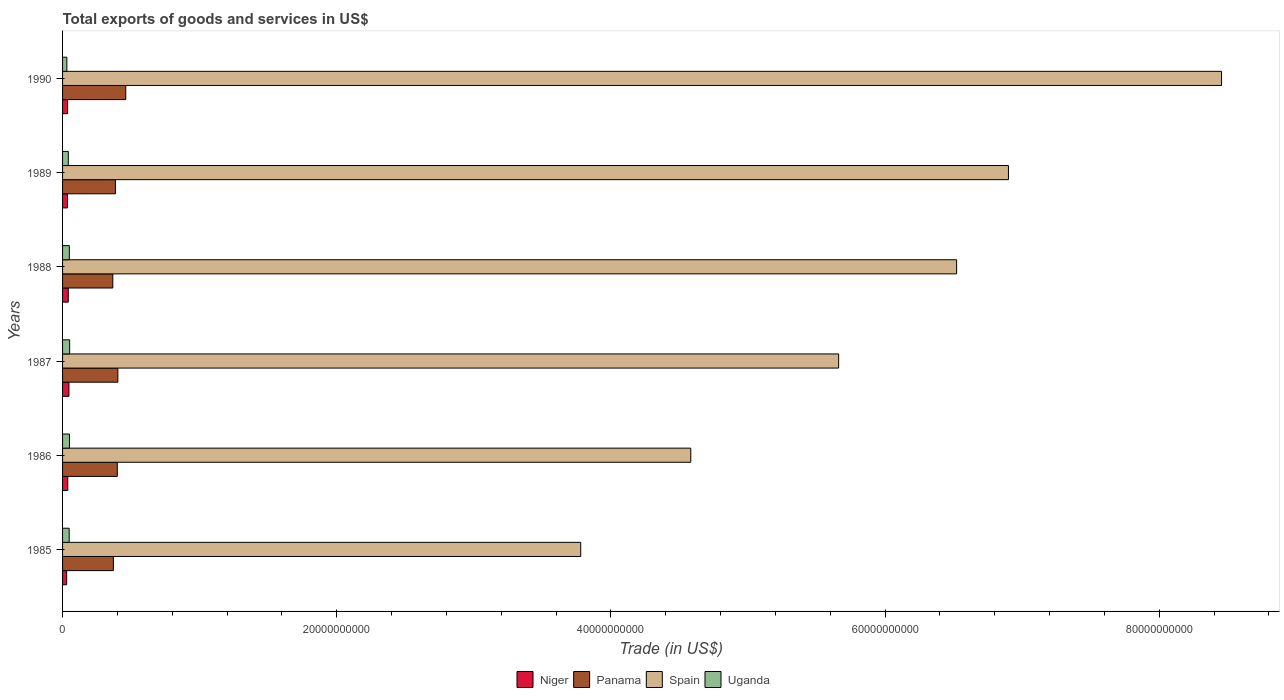How many different coloured bars are there?
Keep it short and to the point. 4. How many groups of bars are there?
Offer a very short reply. 6. Are the number of bars per tick equal to the number of legend labels?
Give a very brief answer. Yes. Are the number of bars on each tick of the Y-axis equal?
Ensure brevity in your answer.  Yes. How many bars are there on the 6th tick from the top?
Offer a very short reply. 4. How many bars are there on the 1st tick from the bottom?
Offer a terse response. 4. In how many cases, is the number of bars for a given year not equal to the number of legend labels?
Provide a succinct answer. 0. What is the total exports of goods and services in Niger in 1986?
Your answer should be compact. 3.81e+08. Across all years, what is the maximum total exports of goods and services in Niger?
Offer a very short reply. 4.65e+08. Across all years, what is the minimum total exports of goods and services in Uganda?
Provide a succinct answer. 3.12e+08. In which year was the total exports of goods and services in Spain maximum?
Your answer should be very brief. 1990. In which year was the total exports of goods and services in Spain minimum?
Your answer should be very brief. 1985. What is the total total exports of goods and services in Panama in the graph?
Ensure brevity in your answer.  2.39e+1. What is the difference between the total exports of goods and services in Niger in 1985 and that in 1988?
Give a very brief answer. -1.19e+08. What is the difference between the total exports of goods and services in Uganda in 1989 and the total exports of goods and services in Niger in 1986?
Your answer should be compact. 3.89e+07. What is the average total exports of goods and services in Spain per year?
Make the answer very short. 5.98e+1. In the year 1987, what is the difference between the total exports of goods and services in Uganda and total exports of goods and services in Spain?
Make the answer very short. -5.61e+1. What is the ratio of the total exports of goods and services in Spain in 1987 to that in 1989?
Your answer should be very brief. 0.82. What is the difference between the highest and the second highest total exports of goods and services in Spain?
Your answer should be compact. 1.55e+1. What is the difference between the highest and the lowest total exports of goods and services in Niger?
Offer a very short reply. 1.67e+08. In how many years, is the total exports of goods and services in Uganda greater than the average total exports of goods and services in Uganda taken over all years?
Offer a very short reply. 4. Is it the case that in every year, the sum of the total exports of goods and services in Uganda and total exports of goods and services in Panama is greater than the sum of total exports of goods and services in Niger and total exports of goods and services in Spain?
Your response must be concise. No. What does the 2nd bar from the top in 1990 represents?
Offer a very short reply. Spain. What does the 1st bar from the bottom in 1986 represents?
Ensure brevity in your answer.  Niger. Is it the case that in every year, the sum of the total exports of goods and services in Uganda and total exports of goods and services in Spain is greater than the total exports of goods and services in Niger?
Provide a short and direct response. Yes. How many bars are there?
Keep it short and to the point. 24. Are all the bars in the graph horizontal?
Your answer should be compact. Yes. How many years are there in the graph?
Provide a succinct answer. 6. Where does the legend appear in the graph?
Provide a short and direct response. Bottom center. How many legend labels are there?
Offer a very short reply. 4. What is the title of the graph?
Offer a very short reply. Total exports of goods and services in US$. Does "Tonga" appear as one of the legend labels in the graph?
Provide a succinct answer. No. What is the label or title of the X-axis?
Give a very brief answer. Trade (in US$). What is the label or title of the Y-axis?
Offer a very short reply. Years. What is the Trade (in US$) of Niger in 1985?
Your answer should be compact. 2.98e+08. What is the Trade (in US$) in Panama in 1985?
Keep it short and to the point. 3.71e+09. What is the Trade (in US$) of Spain in 1985?
Give a very brief answer. 3.78e+1. What is the Trade (in US$) in Uganda in 1985?
Ensure brevity in your answer.  4.84e+08. What is the Trade (in US$) of Niger in 1986?
Provide a short and direct response. 3.81e+08. What is the Trade (in US$) of Panama in 1986?
Keep it short and to the point. 3.99e+09. What is the Trade (in US$) in Spain in 1986?
Your answer should be compact. 4.58e+1. What is the Trade (in US$) in Uganda in 1986?
Give a very brief answer. 5.03e+08. What is the Trade (in US$) of Niger in 1987?
Give a very brief answer. 4.65e+08. What is the Trade (in US$) in Panama in 1987?
Provide a succinct answer. 4.03e+09. What is the Trade (in US$) of Spain in 1987?
Your response must be concise. 5.66e+1. What is the Trade (in US$) of Uganda in 1987?
Your answer should be very brief. 5.17e+08. What is the Trade (in US$) of Niger in 1988?
Ensure brevity in your answer.  4.17e+08. What is the Trade (in US$) of Panama in 1988?
Offer a very short reply. 3.67e+09. What is the Trade (in US$) of Spain in 1988?
Your answer should be very brief. 6.52e+1. What is the Trade (in US$) in Uganda in 1988?
Ensure brevity in your answer.  4.93e+08. What is the Trade (in US$) in Niger in 1989?
Ensure brevity in your answer.  3.62e+08. What is the Trade (in US$) in Panama in 1989?
Offer a terse response. 3.86e+09. What is the Trade (in US$) of Spain in 1989?
Give a very brief answer. 6.90e+1. What is the Trade (in US$) of Uganda in 1989?
Your answer should be compact. 4.20e+08. What is the Trade (in US$) in Niger in 1990?
Make the answer very short. 3.67e+08. What is the Trade (in US$) of Panama in 1990?
Offer a terse response. 4.61e+09. What is the Trade (in US$) of Spain in 1990?
Ensure brevity in your answer.  8.45e+1. What is the Trade (in US$) in Uganda in 1990?
Ensure brevity in your answer.  3.12e+08. Across all years, what is the maximum Trade (in US$) in Niger?
Provide a succinct answer. 4.65e+08. Across all years, what is the maximum Trade (in US$) of Panama?
Make the answer very short. 4.61e+09. Across all years, what is the maximum Trade (in US$) of Spain?
Keep it short and to the point. 8.45e+1. Across all years, what is the maximum Trade (in US$) in Uganda?
Offer a terse response. 5.17e+08. Across all years, what is the minimum Trade (in US$) in Niger?
Provide a succinct answer. 2.98e+08. Across all years, what is the minimum Trade (in US$) of Panama?
Offer a terse response. 3.67e+09. Across all years, what is the minimum Trade (in US$) in Spain?
Ensure brevity in your answer.  3.78e+1. Across all years, what is the minimum Trade (in US$) in Uganda?
Your answer should be compact. 3.12e+08. What is the total Trade (in US$) in Niger in the graph?
Your response must be concise. 2.29e+09. What is the total Trade (in US$) of Panama in the graph?
Give a very brief answer. 2.39e+1. What is the total Trade (in US$) of Spain in the graph?
Provide a short and direct response. 3.59e+11. What is the total Trade (in US$) of Uganda in the graph?
Provide a short and direct response. 2.73e+09. What is the difference between the Trade (in US$) in Niger in 1985 and that in 1986?
Provide a succinct answer. -8.28e+07. What is the difference between the Trade (in US$) of Panama in 1985 and that in 1986?
Keep it short and to the point. -2.86e+08. What is the difference between the Trade (in US$) of Spain in 1985 and that in 1986?
Your answer should be very brief. -8.03e+09. What is the difference between the Trade (in US$) in Uganda in 1985 and that in 1986?
Keep it short and to the point. -1.90e+07. What is the difference between the Trade (in US$) in Niger in 1985 and that in 1987?
Offer a very short reply. -1.67e+08. What is the difference between the Trade (in US$) of Panama in 1985 and that in 1987?
Provide a succinct answer. -3.26e+08. What is the difference between the Trade (in US$) in Spain in 1985 and that in 1987?
Ensure brevity in your answer.  -1.88e+1. What is the difference between the Trade (in US$) in Uganda in 1985 and that in 1987?
Your response must be concise. -3.35e+07. What is the difference between the Trade (in US$) of Niger in 1985 and that in 1988?
Your answer should be very brief. -1.19e+08. What is the difference between the Trade (in US$) in Panama in 1985 and that in 1988?
Give a very brief answer. 4.05e+07. What is the difference between the Trade (in US$) of Spain in 1985 and that in 1988?
Provide a short and direct response. -2.74e+1. What is the difference between the Trade (in US$) of Uganda in 1985 and that in 1988?
Make the answer very short. -9.35e+06. What is the difference between the Trade (in US$) of Niger in 1985 and that in 1989?
Give a very brief answer. -6.38e+07. What is the difference between the Trade (in US$) in Panama in 1985 and that in 1989?
Your answer should be very brief. -1.50e+08. What is the difference between the Trade (in US$) of Spain in 1985 and that in 1989?
Provide a short and direct response. -3.12e+1. What is the difference between the Trade (in US$) of Uganda in 1985 and that in 1989?
Offer a very short reply. 6.38e+07. What is the difference between the Trade (in US$) in Niger in 1985 and that in 1990?
Your answer should be very brief. -6.94e+07. What is the difference between the Trade (in US$) of Panama in 1985 and that in 1990?
Offer a very short reply. -9.05e+08. What is the difference between the Trade (in US$) in Spain in 1985 and that in 1990?
Make the answer very short. -4.67e+1. What is the difference between the Trade (in US$) in Uganda in 1985 and that in 1990?
Provide a succinct answer. 1.72e+08. What is the difference between the Trade (in US$) in Niger in 1986 and that in 1987?
Make the answer very short. -8.37e+07. What is the difference between the Trade (in US$) in Panama in 1986 and that in 1987?
Offer a terse response. -3.92e+07. What is the difference between the Trade (in US$) in Spain in 1986 and that in 1987?
Make the answer very short. -1.08e+1. What is the difference between the Trade (in US$) in Uganda in 1986 and that in 1987?
Offer a very short reply. -1.45e+07. What is the difference between the Trade (in US$) in Niger in 1986 and that in 1988?
Your answer should be compact. -3.65e+07. What is the difference between the Trade (in US$) of Panama in 1986 and that in 1988?
Keep it short and to the point. 3.27e+08. What is the difference between the Trade (in US$) in Spain in 1986 and that in 1988?
Make the answer very short. -1.94e+1. What is the difference between the Trade (in US$) in Uganda in 1986 and that in 1988?
Provide a succinct answer. 9.67e+06. What is the difference between the Trade (in US$) in Niger in 1986 and that in 1989?
Offer a terse response. 1.90e+07. What is the difference between the Trade (in US$) of Panama in 1986 and that in 1989?
Give a very brief answer. 1.36e+08. What is the difference between the Trade (in US$) in Spain in 1986 and that in 1989?
Give a very brief answer. -2.32e+1. What is the difference between the Trade (in US$) in Uganda in 1986 and that in 1989?
Give a very brief answer. 8.29e+07. What is the difference between the Trade (in US$) in Niger in 1986 and that in 1990?
Make the answer very short. 1.34e+07. What is the difference between the Trade (in US$) in Panama in 1986 and that in 1990?
Ensure brevity in your answer.  -6.18e+08. What is the difference between the Trade (in US$) in Spain in 1986 and that in 1990?
Offer a very short reply. -3.87e+1. What is the difference between the Trade (in US$) in Uganda in 1986 and that in 1990?
Your answer should be compact. 1.91e+08. What is the difference between the Trade (in US$) in Niger in 1987 and that in 1988?
Ensure brevity in your answer.  4.72e+07. What is the difference between the Trade (in US$) of Panama in 1987 and that in 1988?
Your answer should be very brief. 3.66e+08. What is the difference between the Trade (in US$) of Spain in 1987 and that in 1988?
Provide a succinct answer. -8.61e+09. What is the difference between the Trade (in US$) of Uganda in 1987 and that in 1988?
Provide a succinct answer. 2.42e+07. What is the difference between the Trade (in US$) in Niger in 1987 and that in 1989?
Ensure brevity in your answer.  1.03e+08. What is the difference between the Trade (in US$) in Panama in 1987 and that in 1989?
Offer a very short reply. 1.76e+08. What is the difference between the Trade (in US$) of Spain in 1987 and that in 1989?
Your answer should be compact. -1.24e+1. What is the difference between the Trade (in US$) in Uganda in 1987 and that in 1989?
Provide a succinct answer. 9.73e+07. What is the difference between the Trade (in US$) of Niger in 1987 and that in 1990?
Keep it short and to the point. 9.71e+07. What is the difference between the Trade (in US$) of Panama in 1987 and that in 1990?
Your response must be concise. -5.79e+08. What is the difference between the Trade (in US$) in Spain in 1987 and that in 1990?
Provide a succinct answer. -2.79e+1. What is the difference between the Trade (in US$) of Uganda in 1987 and that in 1990?
Offer a terse response. 2.05e+08. What is the difference between the Trade (in US$) of Niger in 1988 and that in 1989?
Your response must be concise. 5.55e+07. What is the difference between the Trade (in US$) of Panama in 1988 and that in 1989?
Ensure brevity in your answer.  -1.91e+08. What is the difference between the Trade (in US$) in Spain in 1988 and that in 1989?
Offer a terse response. -3.78e+09. What is the difference between the Trade (in US$) of Uganda in 1988 and that in 1989?
Make the answer very short. 7.32e+07. What is the difference between the Trade (in US$) in Niger in 1988 and that in 1990?
Your answer should be compact. 4.99e+07. What is the difference between the Trade (in US$) in Panama in 1988 and that in 1990?
Offer a terse response. -9.45e+08. What is the difference between the Trade (in US$) in Spain in 1988 and that in 1990?
Ensure brevity in your answer.  -1.93e+1. What is the difference between the Trade (in US$) in Uganda in 1988 and that in 1990?
Offer a very short reply. 1.81e+08. What is the difference between the Trade (in US$) of Niger in 1989 and that in 1990?
Your answer should be very brief. -5.61e+06. What is the difference between the Trade (in US$) in Panama in 1989 and that in 1990?
Offer a very short reply. -7.54e+08. What is the difference between the Trade (in US$) of Spain in 1989 and that in 1990?
Your response must be concise. -1.55e+1. What is the difference between the Trade (in US$) in Uganda in 1989 and that in 1990?
Provide a short and direct response. 1.08e+08. What is the difference between the Trade (in US$) of Niger in 1985 and the Trade (in US$) of Panama in 1986?
Offer a terse response. -3.69e+09. What is the difference between the Trade (in US$) in Niger in 1985 and the Trade (in US$) in Spain in 1986?
Ensure brevity in your answer.  -4.55e+1. What is the difference between the Trade (in US$) of Niger in 1985 and the Trade (in US$) of Uganda in 1986?
Keep it short and to the point. -2.05e+08. What is the difference between the Trade (in US$) of Panama in 1985 and the Trade (in US$) of Spain in 1986?
Give a very brief answer. -4.21e+1. What is the difference between the Trade (in US$) of Panama in 1985 and the Trade (in US$) of Uganda in 1986?
Your answer should be compact. 3.20e+09. What is the difference between the Trade (in US$) in Spain in 1985 and the Trade (in US$) in Uganda in 1986?
Keep it short and to the point. 3.73e+1. What is the difference between the Trade (in US$) in Niger in 1985 and the Trade (in US$) in Panama in 1987?
Provide a succinct answer. -3.73e+09. What is the difference between the Trade (in US$) in Niger in 1985 and the Trade (in US$) in Spain in 1987?
Offer a very short reply. -5.63e+1. What is the difference between the Trade (in US$) in Niger in 1985 and the Trade (in US$) in Uganda in 1987?
Your response must be concise. -2.19e+08. What is the difference between the Trade (in US$) of Panama in 1985 and the Trade (in US$) of Spain in 1987?
Make the answer very short. -5.29e+1. What is the difference between the Trade (in US$) in Panama in 1985 and the Trade (in US$) in Uganda in 1987?
Provide a short and direct response. 3.19e+09. What is the difference between the Trade (in US$) in Spain in 1985 and the Trade (in US$) in Uganda in 1987?
Offer a very short reply. 3.73e+1. What is the difference between the Trade (in US$) in Niger in 1985 and the Trade (in US$) in Panama in 1988?
Your response must be concise. -3.37e+09. What is the difference between the Trade (in US$) of Niger in 1985 and the Trade (in US$) of Spain in 1988?
Keep it short and to the point. -6.49e+1. What is the difference between the Trade (in US$) in Niger in 1985 and the Trade (in US$) in Uganda in 1988?
Offer a very short reply. -1.95e+08. What is the difference between the Trade (in US$) in Panama in 1985 and the Trade (in US$) in Spain in 1988?
Your answer should be very brief. -6.15e+1. What is the difference between the Trade (in US$) in Panama in 1985 and the Trade (in US$) in Uganda in 1988?
Provide a succinct answer. 3.21e+09. What is the difference between the Trade (in US$) in Spain in 1985 and the Trade (in US$) in Uganda in 1988?
Offer a terse response. 3.73e+1. What is the difference between the Trade (in US$) in Niger in 1985 and the Trade (in US$) in Panama in 1989?
Give a very brief answer. -3.56e+09. What is the difference between the Trade (in US$) in Niger in 1985 and the Trade (in US$) in Spain in 1989?
Your answer should be very brief. -6.87e+1. What is the difference between the Trade (in US$) in Niger in 1985 and the Trade (in US$) in Uganda in 1989?
Make the answer very short. -1.22e+08. What is the difference between the Trade (in US$) of Panama in 1985 and the Trade (in US$) of Spain in 1989?
Your response must be concise. -6.53e+1. What is the difference between the Trade (in US$) of Panama in 1985 and the Trade (in US$) of Uganda in 1989?
Offer a terse response. 3.29e+09. What is the difference between the Trade (in US$) in Spain in 1985 and the Trade (in US$) in Uganda in 1989?
Keep it short and to the point. 3.74e+1. What is the difference between the Trade (in US$) in Niger in 1985 and the Trade (in US$) in Panama in 1990?
Ensure brevity in your answer.  -4.31e+09. What is the difference between the Trade (in US$) of Niger in 1985 and the Trade (in US$) of Spain in 1990?
Your answer should be very brief. -8.42e+1. What is the difference between the Trade (in US$) of Niger in 1985 and the Trade (in US$) of Uganda in 1990?
Keep it short and to the point. -1.37e+07. What is the difference between the Trade (in US$) in Panama in 1985 and the Trade (in US$) in Spain in 1990?
Your answer should be very brief. -8.08e+1. What is the difference between the Trade (in US$) in Panama in 1985 and the Trade (in US$) in Uganda in 1990?
Give a very brief answer. 3.39e+09. What is the difference between the Trade (in US$) of Spain in 1985 and the Trade (in US$) of Uganda in 1990?
Your answer should be compact. 3.75e+1. What is the difference between the Trade (in US$) in Niger in 1986 and the Trade (in US$) in Panama in 1987?
Your response must be concise. -3.65e+09. What is the difference between the Trade (in US$) in Niger in 1986 and the Trade (in US$) in Spain in 1987?
Ensure brevity in your answer.  -5.62e+1. What is the difference between the Trade (in US$) of Niger in 1986 and the Trade (in US$) of Uganda in 1987?
Provide a succinct answer. -1.36e+08. What is the difference between the Trade (in US$) in Panama in 1986 and the Trade (in US$) in Spain in 1987?
Make the answer very short. -5.26e+1. What is the difference between the Trade (in US$) in Panama in 1986 and the Trade (in US$) in Uganda in 1987?
Provide a succinct answer. 3.48e+09. What is the difference between the Trade (in US$) in Spain in 1986 and the Trade (in US$) in Uganda in 1987?
Offer a terse response. 4.53e+1. What is the difference between the Trade (in US$) of Niger in 1986 and the Trade (in US$) of Panama in 1988?
Provide a succinct answer. -3.28e+09. What is the difference between the Trade (in US$) of Niger in 1986 and the Trade (in US$) of Spain in 1988?
Keep it short and to the point. -6.48e+1. What is the difference between the Trade (in US$) in Niger in 1986 and the Trade (in US$) in Uganda in 1988?
Ensure brevity in your answer.  -1.12e+08. What is the difference between the Trade (in US$) in Panama in 1986 and the Trade (in US$) in Spain in 1988?
Your answer should be very brief. -6.12e+1. What is the difference between the Trade (in US$) in Panama in 1986 and the Trade (in US$) in Uganda in 1988?
Your answer should be very brief. 3.50e+09. What is the difference between the Trade (in US$) in Spain in 1986 and the Trade (in US$) in Uganda in 1988?
Provide a short and direct response. 4.53e+1. What is the difference between the Trade (in US$) in Niger in 1986 and the Trade (in US$) in Panama in 1989?
Offer a terse response. -3.48e+09. What is the difference between the Trade (in US$) in Niger in 1986 and the Trade (in US$) in Spain in 1989?
Your answer should be compact. -6.86e+1. What is the difference between the Trade (in US$) in Niger in 1986 and the Trade (in US$) in Uganda in 1989?
Make the answer very short. -3.89e+07. What is the difference between the Trade (in US$) of Panama in 1986 and the Trade (in US$) of Spain in 1989?
Your response must be concise. -6.50e+1. What is the difference between the Trade (in US$) in Panama in 1986 and the Trade (in US$) in Uganda in 1989?
Make the answer very short. 3.57e+09. What is the difference between the Trade (in US$) of Spain in 1986 and the Trade (in US$) of Uganda in 1989?
Ensure brevity in your answer.  4.54e+1. What is the difference between the Trade (in US$) of Niger in 1986 and the Trade (in US$) of Panama in 1990?
Give a very brief answer. -4.23e+09. What is the difference between the Trade (in US$) in Niger in 1986 and the Trade (in US$) in Spain in 1990?
Your answer should be very brief. -8.42e+1. What is the difference between the Trade (in US$) of Niger in 1986 and the Trade (in US$) of Uganda in 1990?
Ensure brevity in your answer.  6.92e+07. What is the difference between the Trade (in US$) in Panama in 1986 and the Trade (in US$) in Spain in 1990?
Offer a terse response. -8.06e+1. What is the difference between the Trade (in US$) of Panama in 1986 and the Trade (in US$) of Uganda in 1990?
Your response must be concise. 3.68e+09. What is the difference between the Trade (in US$) in Spain in 1986 and the Trade (in US$) in Uganda in 1990?
Offer a very short reply. 4.55e+1. What is the difference between the Trade (in US$) of Niger in 1987 and the Trade (in US$) of Panama in 1988?
Provide a short and direct response. -3.20e+09. What is the difference between the Trade (in US$) in Niger in 1987 and the Trade (in US$) in Spain in 1988?
Offer a very short reply. -6.48e+1. What is the difference between the Trade (in US$) in Niger in 1987 and the Trade (in US$) in Uganda in 1988?
Your answer should be very brief. -2.84e+07. What is the difference between the Trade (in US$) of Panama in 1987 and the Trade (in US$) of Spain in 1988?
Provide a short and direct response. -6.12e+1. What is the difference between the Trade (in US$) of Panama in 1987 and the Trade (in US$) of Uganda in 1988?
Your answer should be very brief. 3.54e+09. What is the difference between the Trade (in US$) in Spain in 1987 and the Trade (in US$) in Uganda in 1988?
Make the answer very short. 5.61e+1. What is the difference between the Trade (in US$) in Niger in 1987 and the Trade (in US$) in Panama in 1989?
Offer a very short reply. -3.39e+09. What is the difference between the Trade (in US$) of Niger in 1987 and the Trade (in US$) of Spain in 1989?
Make the answer very short. -6.85e+1. What is the difference between the Trade (in US$) of Niger in 1987 and the Trade (in US$) of Uganda in 1989?
Your answer should be very brief. 4.48e+07. What is the difference between the Trade (in US$) in Panama in 1987 and the Trade (in US$) in Spain in 1989?
Offer a terse response. -6.50e+1. What is the difference between the Trade (in US$) of Panama in 1987 and the Trade (in US$) of Uganda in 1989?
Provide a short and direct response. 3.61e+09. What is the difference between the Trade (in US$) of Spain in 1987 and the Trade (in US$) of Uganda in 1989?
Provide a succinct answer. 5.62e+1. What is the difference between the Trade (in US$) of Niger in 1987 and the Trade (in US$) of Panama in 1990?
Your response must be concise. -4.15e+09. What is the difference between the Trade (in US$) of Niger in 1987 and the Trade (in US$) of Spain in 1990?
Give a very brief answer. -8.41e+1. What is the difference between the Trade (in US$) of Niger in 1987 and the Trade (in US$) of Uganda in 1990?
Make the answer very short. 1.53e+08. What is the difference between the Trade (in US$) in Panama in 1987 and the Trade (in US$) in Spain in 1990?
Ensure brevity in your answer.  -8.05e+1. What is the difference between the Trade (in US$) in Panama in 1987 and the Trade (in US$) in Uganda in 1990?
Give a very brief answer. 3.72e+09. What is the difference between the Trade (in US$) of Spain in 1987 and the Trade (in US$) of Uganda in 1990?
Offer a very short reply. 5.63e+1. What is the difference between the Trade (in US$) in Niger in 1988 and the Trade (in US$) in Panama in 1989?
Offer a terse response. -3.44e+09. What is the difference between the Trade (in US$) of Niger in 1988 and the Trade (in US$) of Spain in 1989?
Offer a terse response. -6.86e+1. What is the difference between the Trade (in US$) of Niger in 1988 and the Trade (in US$) of Uganda in 1989?
Give a very brief answer. -2.41e+06. What is the difference between the Trade (in US$) of Panama in 1988 and the Trade (in US$) of Spain in 1989?
Offer a very short reply. -6.53e+1. What is the difference between the Trade (in US$) of Panama in 1988 and the Trade (in US$) of Uganda in 1989?
Your answer should be very brief. 3.25e+09. What is the difference between the Trade (in US$) in Spain in 1988 and the Trade (in US$) in Uganda in 1989?
Provide a succinct answer. 6.48e+1. What is the difference between the Trade (in US$) of Niger in 1988 and the Trade (in US$) of Panama in 1990?
Provide a short and direct response. -4.19e+09. What is the difference between the Trade (in US$) of Niger in 1988 and the Trade (in US$) of Spain in 1990?
Provide a short and direct response. -8.41e+1. What is the difference between the Trade (in US$) in Niger in 1988 and the Trade (in US$) in Uganda in 1990?
Keep it short and to the point. 1.06e+08. What is the difference between the Trade (in US$) in Panama in 1988 and the Trade (in US$) in Spain in 1990?
Provide a short and direct response. -8.09e+1. What is the difference between the Trade (in US$) in Panama in 1988 and the Trade (in US$) in Uganda in 1990?
Offer a terse response. 3.35e+09. What is the difference between the Trade (in US$) of Spain in 1988 and the Trade (in US$) of Uganda in 1990?
Provide a succinct answer. 6.49e+1. What is the difference between the Trade (in US$) of Niger in 1989 and the Trade (in US$) of Panama in 1990?
Your answer should be compact. -4.25e+09. What is the difference between the Trade (in US$) in Niger in 1989 and the Trade (in US$) in Spain in 1990?
Provide a short and direct response. -8.42e+1. What is the difference between the Trade (in US$) in Niger in 1989 and the Trade (in US$) in Uganda in 1990?
Your answer should be very brief. 5.01e+07. What is the difference between the Trade (in US$) in Panama in 1989 and the Trade (in US$) in Spain in 1990?
Your response must be concise. -8.07e+1. What is the difference between the Trade (in US$) of Panama in 1989 and the Trade (in US$) of Uganda in 1990?
Give a very brief answer. 3.54e+09. What is the difference between the Trade (in US$) in Spain in 1989 and the Trade (in US$) in Uganda in 1990?
Ensure brevity in your answer.  6.87e+1. What is the average Trade (in US$) of Niger per year?
Offer a terse response. 3.82e+08. What is the average Trade (in US$) of Panama per year?
Your answer should be very brief. 3.98e+09. What is the average Trade (in US$) in Spain per year?
Ensure brevity in your answer.  5.98e+1. What is the average Trade (in US$) in Uganda per year?
Your response must be concise. 4.55e+08. In the year 1985, what is the difference between the Trade (in US$) of Niger and Trade (in US$) of Panama?
Provide a short and direct response. -3.41e+09. In the year 1985, what is the difference between the Trade (in US$) of Niger and Trade (in US$) of Spain?
Your answer should be compact. -3.75e+1. In the year 1985, what is the difference between the Trade (in US$) in Niger and Trade (in US$) in Uganda?
Your answer should be very brief. -1.86e+08. In the year 1985, what is the difference between the Trade (in US$) of Panama and Trade (in US$) of Spain?
Your response must be concise. -3.41e+1. In the year 1985, what is the difference between the Trade (in US$) of Panama and Trade (in US$) of Uganda?
Your answer should be compact. 3.22e+09. In the year 1985, what is the difference between the Trade (in US$) of Spain and Trade (in US$) of Uganda?
Your response must be concise. 3.73e+1. In the year 1986, what is the difference between the Trade (in US$) of Niger and Trade (in US$) of Panama?
Offer a very short reply. -3.61e+09. In the year 1986, what is the difference between the Trade (in US$) in Niger and Trade (in US$) in Spain?
Provide a succinct answer. -4.54e+1. In the year 1986, what is the difference between the Trade (in US$) in Niger and Trade (in US$) in Uganda?
Provide a succinct answer. -1.22e+08. In the year 1986, what is the difference between the Trade (in US$) in Panama and Trade (in US$) in Spain?
Offer a terse response. -4.18e+1. In the year 1986, what is the difference between the Trade (in US$) of Panama and Trade (in US$) of Uganda?
Your response must be concise. 3.49e+09. In the year 1986, what is the difference between the Trade (in US$) in Spain and Trade (in US$) in Uganda?
Keep it short and to the point. 4.53e+1. In the year 1987, what is the difference between the Trade (in US$) in Niger and Trade (in US$) in Panama?
Give a very brief answer. -3.57e+09. In the year 1987, what is the difference between the Trade (in US$) of Niger and Trade (in US$) of Spain?
Provide a short and direct response. -5.61e+1. In the year 1987, what is the difference between the Trade (in US$) of Niger and Trade (in US$) of Uganda?
Your response must be concise. -5.25e+07. In the year 1987, what is the difference between the Trade (in US$) in Panama and Trade (in US$) in Spain?
Provide a succinct answer. -5.26e+1. In the year 1987, what is the difference between the Trade (in US$) in Panama and Trade (in US$) in Uganda?
Provide a succinct answer. 3.51e+09. In the year 1987, what is the difference between the Trade (in US$) of Spain and Trade (in US$) of Uganda?
Give a very brief answer. 5.61e+1. In the year 1988, what is the difference between the Trade (in US$) of Niger and Trade (in US$) of Panama?
Ensure brevity in your answer.  -3.25e+09. In the year 1988, what is the difference between the Trade (in US$) of Niger and Trade (in US$) of Spain?
Provide a short and direct response. -6.48e+1. In the year 1988, what is the difference between the Trade (in US$) of Niger and Trade (in US$) of Uganda?
Your response must be concise. -7.56e+07. In the year 1988, what is the difference between the Trade (in US$) in Panama and Trade (in US$) in Spain?
Offer a terse response. -6.16e+1. In the year 1988, what is the difference between the Trade (in US$) of Panama and Trade (in US$) of Uganda?
Make the answer very short. 3.17e+09. In the year 1988, what is the difference between the Trade (in US$) of Spain and Trade (in US$) of Uganda?
Provide a succinct answer. 6.47e+1. In the year 1989, what is the difference between the Trade (in US$) in Niger and Trade (in US$) in Panama?
Give a very brief answer. -3.49e+09. In the year 1989, what is the difference between the Trade (in US$) of Niger and Trade (in US$) of Spain?
Offer a very short reply. -6.86e+1. In the year 1989, what is the difference between the Trade (in US$) in Niger and Trade (in US$) in Uganda?
Give a very brief answer. -5.79e+07. In the year 1989, what is the difference between the Trade (in US$) in Panama and Trade (in US$) in Spain?
Your answer should be compact. -6.51e+1. In the year 1989, what is the difference between the Trade (in US$) in Panama and Trade (in US$) in Uganda?
Your answer should be very brief. 3.44e+09. In the year 1989, what is the difference between the Trade (in US$) of Spain and Trade (in US$) of Uganda?
Provide a short and direct response. 6.86e+1. In the year 1990, what is the difference between the Trade (in US$) of Niger and Trade (in US$) of Panama?
Your response must be concise. -4.24e+09. In the year 1990, what is the difference between the Trade (in US$) of Niger and Trade (in US$) of Spain?
Keep it short and to the point. -8.42e+1. In the year 1990, what is the difference between the Trade (in US$) in Niger and Trade (in US$) in Uganda?
Keep it short and to the point. 5.57e+07. In the year 1990, what is the difference between the Trade (in US$) of Panama and Trade (in US$) of Spain?
Your response must be concise. -7.99e+1. In the year 1990, what is the difference between the Trade (in US$) in Panama and Trade (in US$) in Uganda?
Give a very brief answer. 4.30e+09. In the year 1990, what is the difference between the Trade (in US$) of Spain and Trade (in US$) of Uganda?
Your answer should be compact. 8.42e+1. What is the ratio of the Trade (in US$) in Niger in 1985 to that in 1986?
Your response must be concise. 0.78. What is the ratio of the Trade (in US$) in Panama in 1985 to that in 1986?
Provide a succinct answer. 0.93. What is the ratio of the Trade (in US$) of Spain in 1985 to that in 1986?
Make the answer very short. 0.82. What is the ratio of the Trade (in US$) of Uganda in 1985 to that in 1986?
Provide a short and direct response. 0.96. What is the ratio of the Trade (in US$) of Niger in 1985 to that in 1987?
Your answer should be compact. 0.64. What is the ratio of the Trade (in US$) in Panama in 1985 to that in 1987?
Offer a terse response. 0.92. What is the ratio of the Trade (in US$) of Spain in 1985 to that in 1987?
Provide a short and direct response. 0.67. What is the ratio of the Trade (in US$) of Uganda in 1985 to that in 1987?
Your response must be concise. 0.94. What is the ratio of the Trade (in US$) of Niger in 1985 to that in 1988?
Ensure brevity in your answer.  0.71. What is the ratio of the Trade (in US$) in Panama in 1985 to that in 1988?
Ensure brevity in your answer.  1.01. What is the ratio of the Trade (in US$) of Spain in 1985 to that in 1988?
Provide a short and direct response. 0.58. What is the ratio of the Trade (in US$) of Uganda in 1985 to that in 1988?
Your answer should be very brief. 0.98. What is the ratio of the Trade (in US$) in Niger in 1985 to that in 1989?
Offer a terse response. 0.82. What is the ratio of the Trade (in US$) of Panama in 1985 to that in 1989?
Your response must be concise. 0.96. What is the ratio of the Trade (in US$) of Spain in 1985 to that in 1989?
Your answer should be very brief. 0.55. What is the ratio of the Trade (in US$) in Uganda in 1985 to that in 1989?
Make the answer very short. 1.15. What is the ratio of the Trade (in US$) of Niger in 1985 to that in 1990?
Your answer should be compact. 0.81. What is the ratio of the Trade (in US$) of Panama in 1985 to that in 1990?
Provide a succinct answer. 0.8. What is the ratio of the Trade (in US$) of Spain in 1985 to that in 1990?
Your response must be concise. 0.45. What is the ratio of the Trade (in US$) of Uganda in 1985 to that in 1990?
Your response must be concise. 1.55. What is the ratio of the Trade (in US$) of Niger in 1986 to that in 1987?
Offer a very short reply. 0.82. What is the ratio of the Trade (in US$) in Panama in 1986 to that in 1987?
Offer a very short reply. 0.99. What is the ratio of the Trade (in US$) in Spain in 1986 to that in 1987?
Your answer should be compact. 0.81. What is the ratio of the Trade (in US$) in Niger in 1986 to that in 1988?
Make the answer very short. 0.91. What is the ratio of the Trade (in US$) in Panama in 1986 to that in 1988?
Your response must be concise. 1.09. What is the ratio of the Trade (in US$) in Spain in 1986 to that in 1988?
Your answer should be very brief. 0.7. What is the ratio of the Trade (in US$) in Uganda in 1986 to that in 1988?
Provide a succinct answer. 1.02. What is the ratio of the Trade (in US$) in Niger in 1986 to that in 1989?
Provide a short and direct response. 1.05. What is the ratio of the Trade (in US$) of Panama in 1986 to that in 1989?
Make the answer very short. 1.04. What is the ratio of the Trade (in US$) in Spain in 1986 to that in 1989?
Your response must be concise. 0.66. What is the ratio of the Trade (in US$) in Uganda in 1986 to that in 1989?
Your response must be concise. 1.2. What is the ratio of the Trade (in US$) in Niger in 1986 to that in 1990?
Your answer should be very brief. 1.04. What is the ratio of the Trade (in US$) in Panama in 1986 to that in 1990?
Make the answer very short. 0.87. What is the ratio of the Trade (in US$) of Spain in 1986 to that in 1990?
Provide a short and direct response. 0.54. What is the ratio of the Trade (in US$) in Uganda in 1986 to that in 1990?
Offer a terse response. 1.61. What is the ratio of the Trade (in US$) of Niger in 1987 to that in 1988?
Offer a very short reply. 1.11. What is the ratio of the Trade (in US$) of Panama in 1987 to that in 1988?
Make the answer very short. 1.1. What is the ratio of the Trade (in US$) of Spain in 1987 to that in 1988?
Your answer should be compact. 0.87. What is the ratio of the Trade (in US$) in Uganda in 1987 to that in 1988?
Offer a very short reply. 1.05. What is the ratio of the Trade (in US$) of Niger in 1987 to that in 1989?
Your answer should be compact. 1.28. What is the ratio of the Trade (in US$) in Panama in 1987 to that in 1989?
Your answer should be very brief. 1.05. What is the ratio of the Trade (in US$) of Spain in 1987 to that in 1989?
Offer a very short reply. 0.82. What is the ratio of the Trade (in US$) in Uganda in 1987 to that in 1989?
Ensure brevity in your answer.  1.23. What is the ratio of the Trade (in US$) of Niger in 1987 to that in 1990?
Make the answer very short. 1.26. What is the ratio of the Trade (in US$) of Panama in 1987 to that in 1990?
Your response must be concise. 0.87. What is the ratio of the Trade (in US$) of Spain in 1987 to that in 1990?
Keep it short and to the point. 0.67. What is the ratio of the Trade (in US$) of Uganda in 1987 to that in 1990?
Your answer should be very brief. 1.66. What is the ratio of the Trade (in US$) of Niger in 1988 to that in 1989?
Make the answer very short. 1.15. What is the ratio of the Trade (in US$) in Panama in 1988 to that in 1989?
Keep it short and to the point. 0.95. What is the ratio of the Trade (in US$) of Spain in 1988 to that in 1989?
Your answer should be compact. 0.95. What is the ratio of the Trade (in US$) in Uganda in 1988 to that in 1989?
Ensure brevity in your answer.  1.17. What is the ratio of the Trade (in US$) in Niger in 1988 to that in 1990?
Your response must be concise. 1.14. What is the ratio of the Trade (in US$) in Panama in 1988 to that in 1990?
Offer a very short reply. 0.8. What is the ratio of the Trade (in US$) in Spain in 1988 to that in 1990?
Offer a terse response. 0.77. What is the ratio of the Trade (in US$) in Uganda in 1988 to that in 1990?
Provide a succinct answer. 1.58. What is the ratio of the Trade (in US$) of Niger in 1989 to that in 1990?
Ensure brevity in your answer.  0.98. What is the ratio of the Trade (in US$) of Panama in 1989 to that in 1990?
Ensure brevity in your answer.  0.84. What is the ratio of the Trade (in US$) in Spain in 1989 to that in 1990?
Your answer should be compact. 0.82. What is the ratio of the Trade (in US$) in Uganda in 1989 to that in 1990?
Keep it short and to the point. 1.35. What is the difference between the highest and the second highest Trade (in US$) in Niger?
Provide a succinct answer. 4.72e+07. What is the difference between the highest and the second highest Trade (in US$) of Panama?
Your answer should be very brief. 5.79e+08. What is the difference between the highest and the second highest Trade (in US$) of Spain?
Give a very brief answer. 1.55e+1. What is the difference between the highest and the second highest Trade (in US$) in Uganda?
Give a very brief answer. 1.45e+07. What is the difference between the highest and the lowest Trade (in US$) of Niger?
Ensure brevity in your answer.  1.67e+08. What is the difference between the highest and the lowest Trade (in US$) of Panama?
Your response must be concise. 9.45e+08. What is the difference between the highest and the lowest Trade (in US$) in Spain?
Provide a succinct answer. 4.67e+1. What is the difference between the highest and the lowest Trade (in US$) in Uganda?
Make the answer very short. 2.05e+08. 